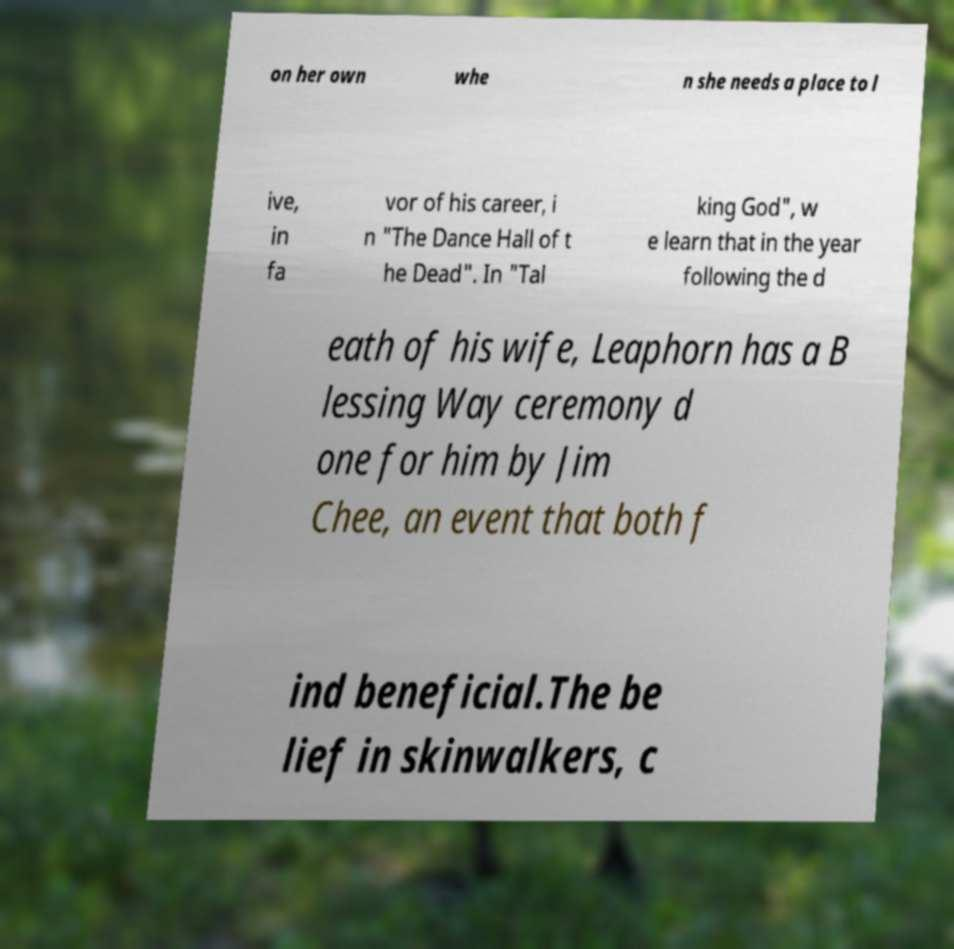Can you accurately transcribe the text from the provided image for me? on her own whe n she needs a place to l ive, in fa vor of his career, i n "The Dance Hall of t he Dead". In "Tal king God", w e learn that in the year following the d eath of his wife, Leaphorn has a B lessing Way ceremony d one for him by Jim Chee, an event that both f ind beneficial.The be lief in skinwalkers, c 